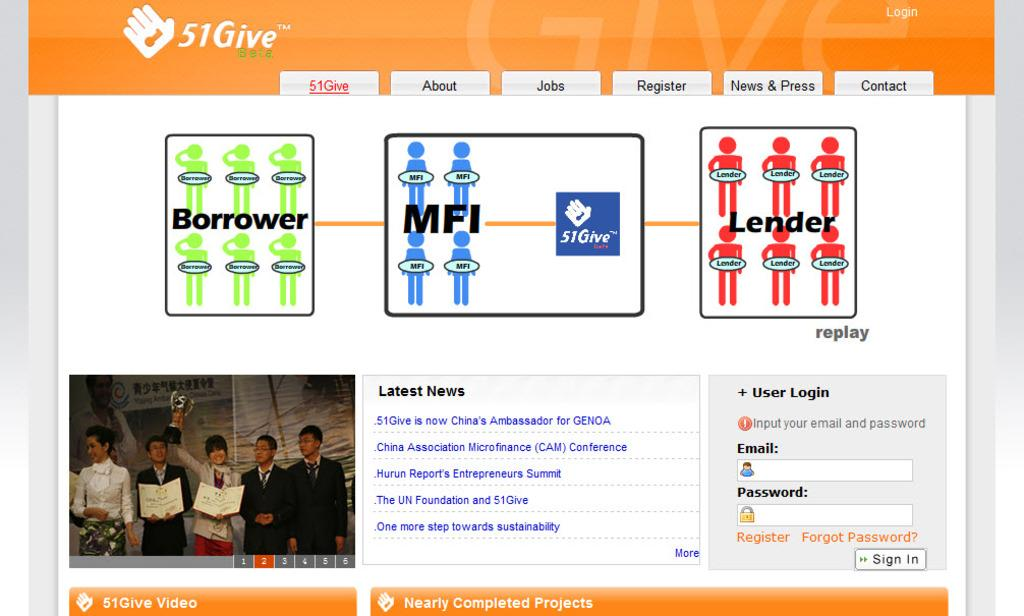What can be seen in the image related to technology? There is a monitor in the image. What is displayed on the monitor? The monitor displays a login page. What information is visible on the login page? The login page has a name "51 give" on it. Can you tell me how many doctors are visible in the image? There are no doctors present in the image. What type of airplane can be seen flying over the monitor in the image? There is no airplane visible in the image; it only shows a monitor with a login page. 